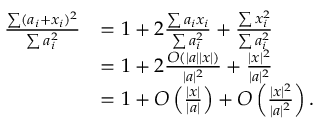<formula> <loc_0><loc_0><loc_500><loc_500>\begin{array} { r l } { \frac { \sum ( a _ { i } + x _ { i } ) ^ { 2 } } { \sum a _ { i } ^ { 2 } } } & { = 1 + 2 \frac { \sum a _ { i } x _ { i } } { \sum a _ { i } ^ { 2 } } + \frac { \sum x _ { i } ^ { 2 } } { \sum a _ { i } ^ { 2 } } } \\ & { = 1 + 2 \frac { O ( | a | | x | ) } { | a | ^ { 2 } } + \frac { | x | ^ { 2 } } { | a | ^ { 2 } } } \\ & { = 1 + O \left ( \frac { | x | } { | a | } \right ) + O \left ( \frac { | x | ^ { 2 } } { | a | ^ { 2 } } \right ) . } \end{array}</formula> 